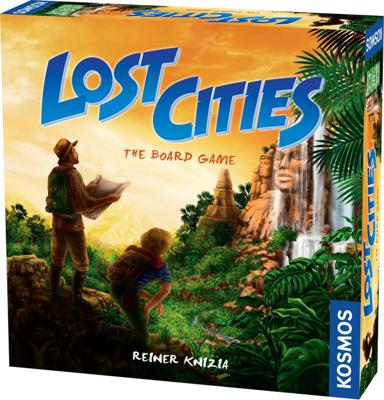Which company produces the game? The game 'Lost Cities' is produced by Kosmos, a company renowned for its wide range of family and educational board games that promote strategic thinking and learning through play. 